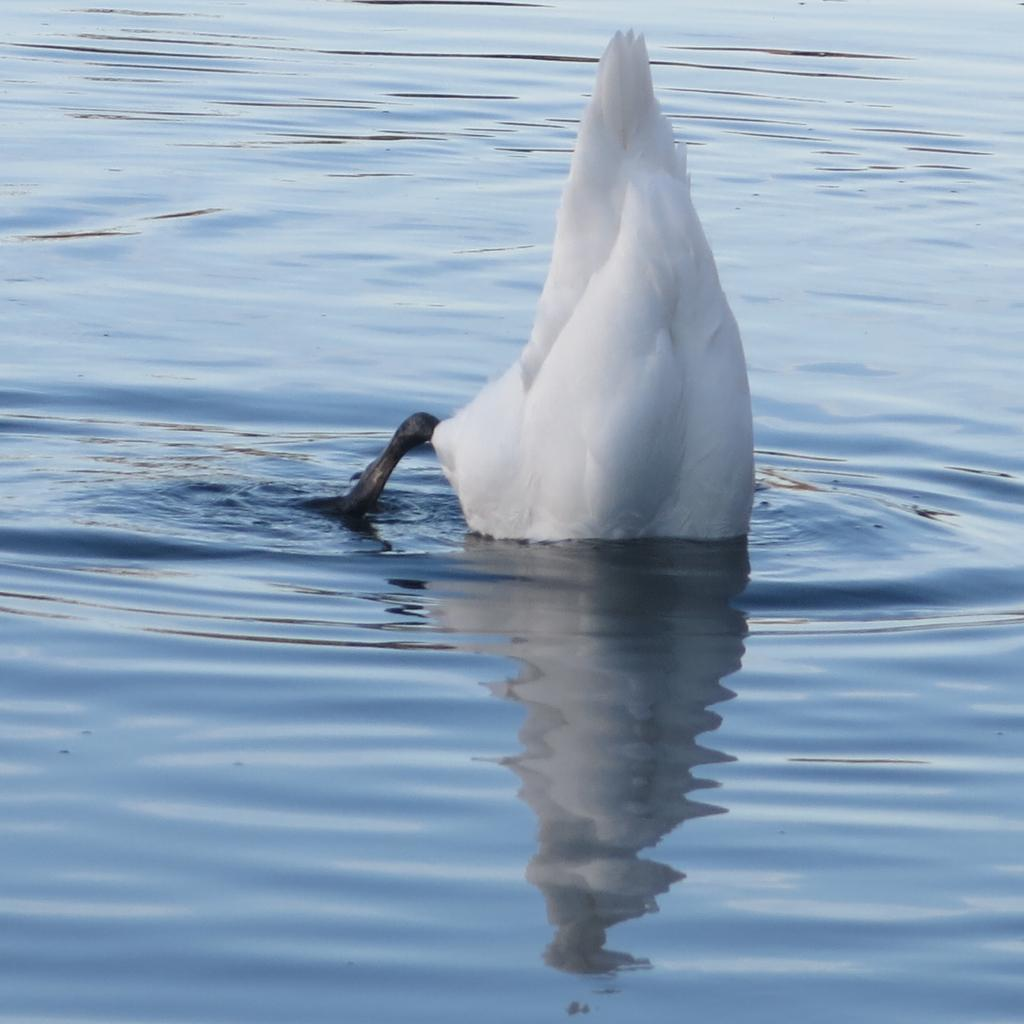What is the primary element visible in the image? There is water in the image. Can you describe any living organisms present in the water? There may be a bird present in the water. What type of canvas is being burned in the image? There is no canvas or burning activity present in the image. 